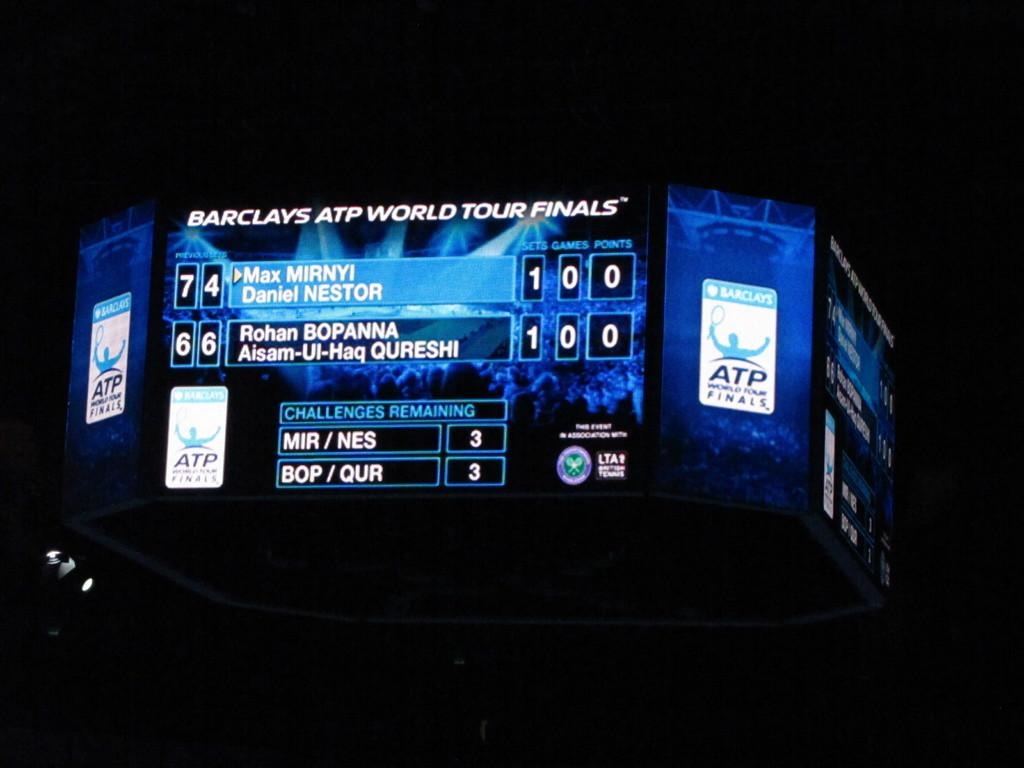<image>
Give a short and clear explanation of the subsequent image. A large montir displaying the score of a game taking place at the Barclays ATP World Tour Finals. 